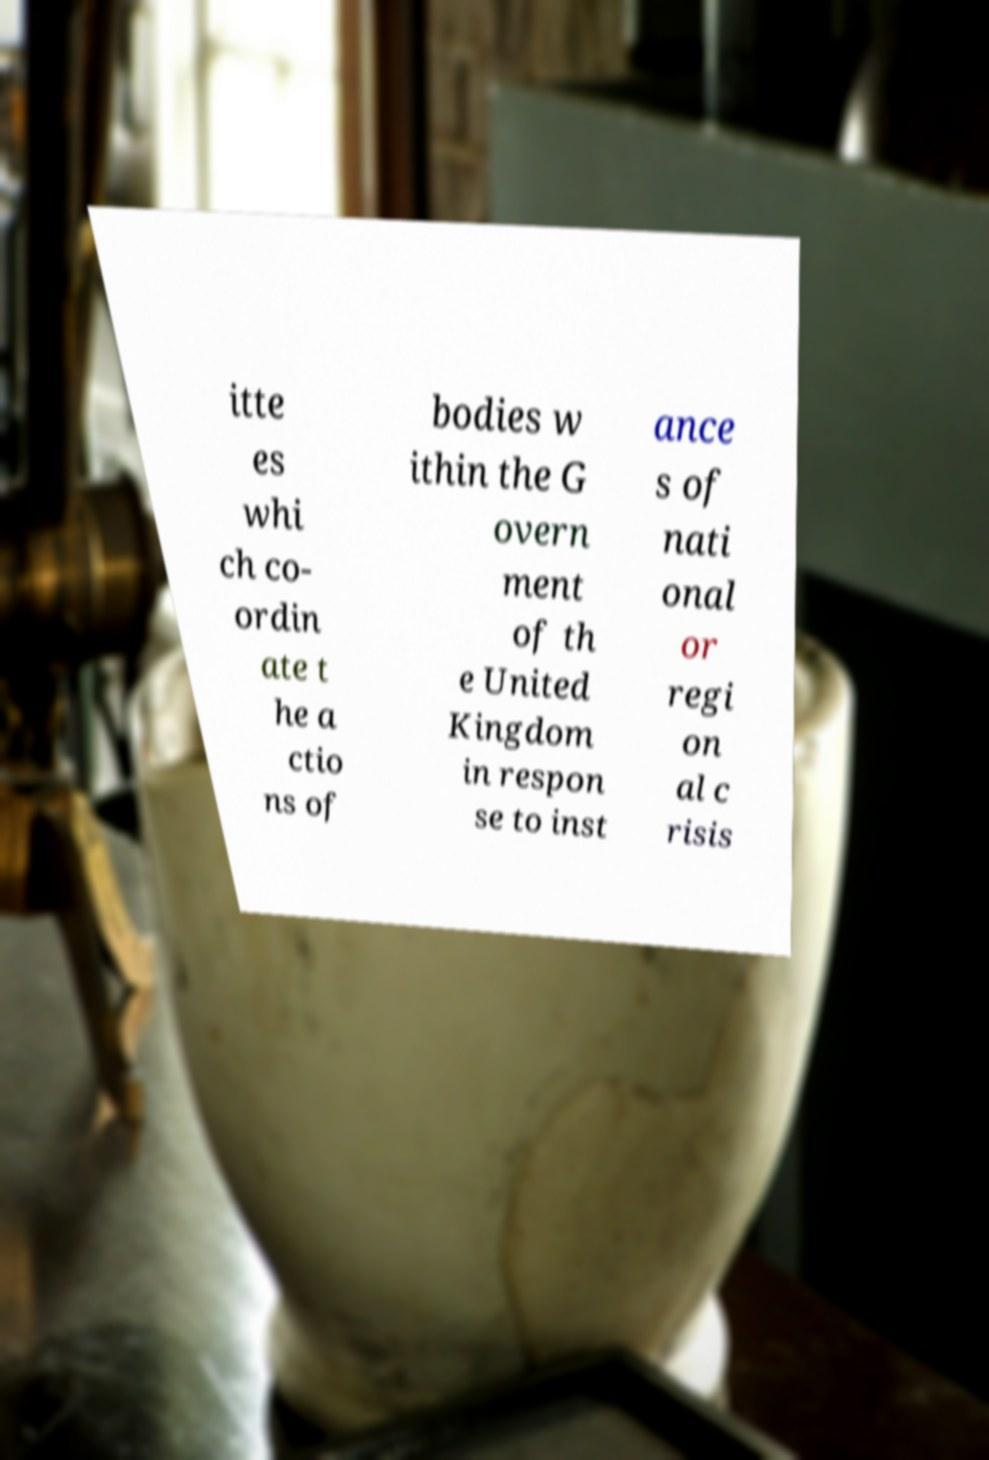For documentation purposes, I need the text within this image transcribed. Could you provide that? itte es whi ch co- ordin ate t he a ctio ns of bodies w ithin the G overn ment of th e United Kingdom in respon se to inst ance s of nati onal or regi on al c risis 